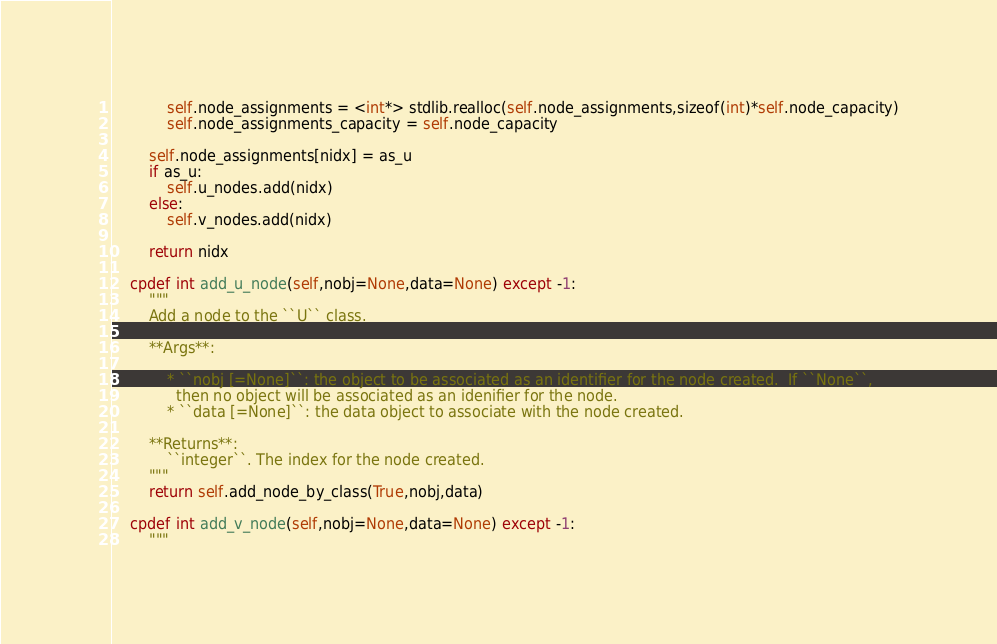<code> <loc_0><loc_0><loc_500><loc_500><_Cython_>			self.node_assignments = <int*> stdlib.realloc(self.node_assignments,sizeof(int)*self.node_capacity)
			self.node_assignments_capacity = self.node_capacity
			
		self.node_assignments[nidx] = as_u
		if as_u:
			self.u_nodes.add(nidx)
		else:
			self.v_nodes.add(nidx)
			
		return nidx
	
	cpdef int add_u_node(self,nobj=None,data=None) except -1:
		"""
		Add a node to the ``U`` class.  
		
		**Args**:
		
			* ``nobj [=None]``: the object to be associated as an identifier for the node created.  If ``None``,
			  then no object will be associated as an idenifier for the node.
			* ``data [=None]``: the data object to associate with the node created.
		
		**Returns**:
			``integer``. The index for the node created.
		"""
		return self.add_node_by_class(True,nobj,data)
		
	cpdef int add_v_node(self,nobj=None,data=None) except -1:
		"""</code> 